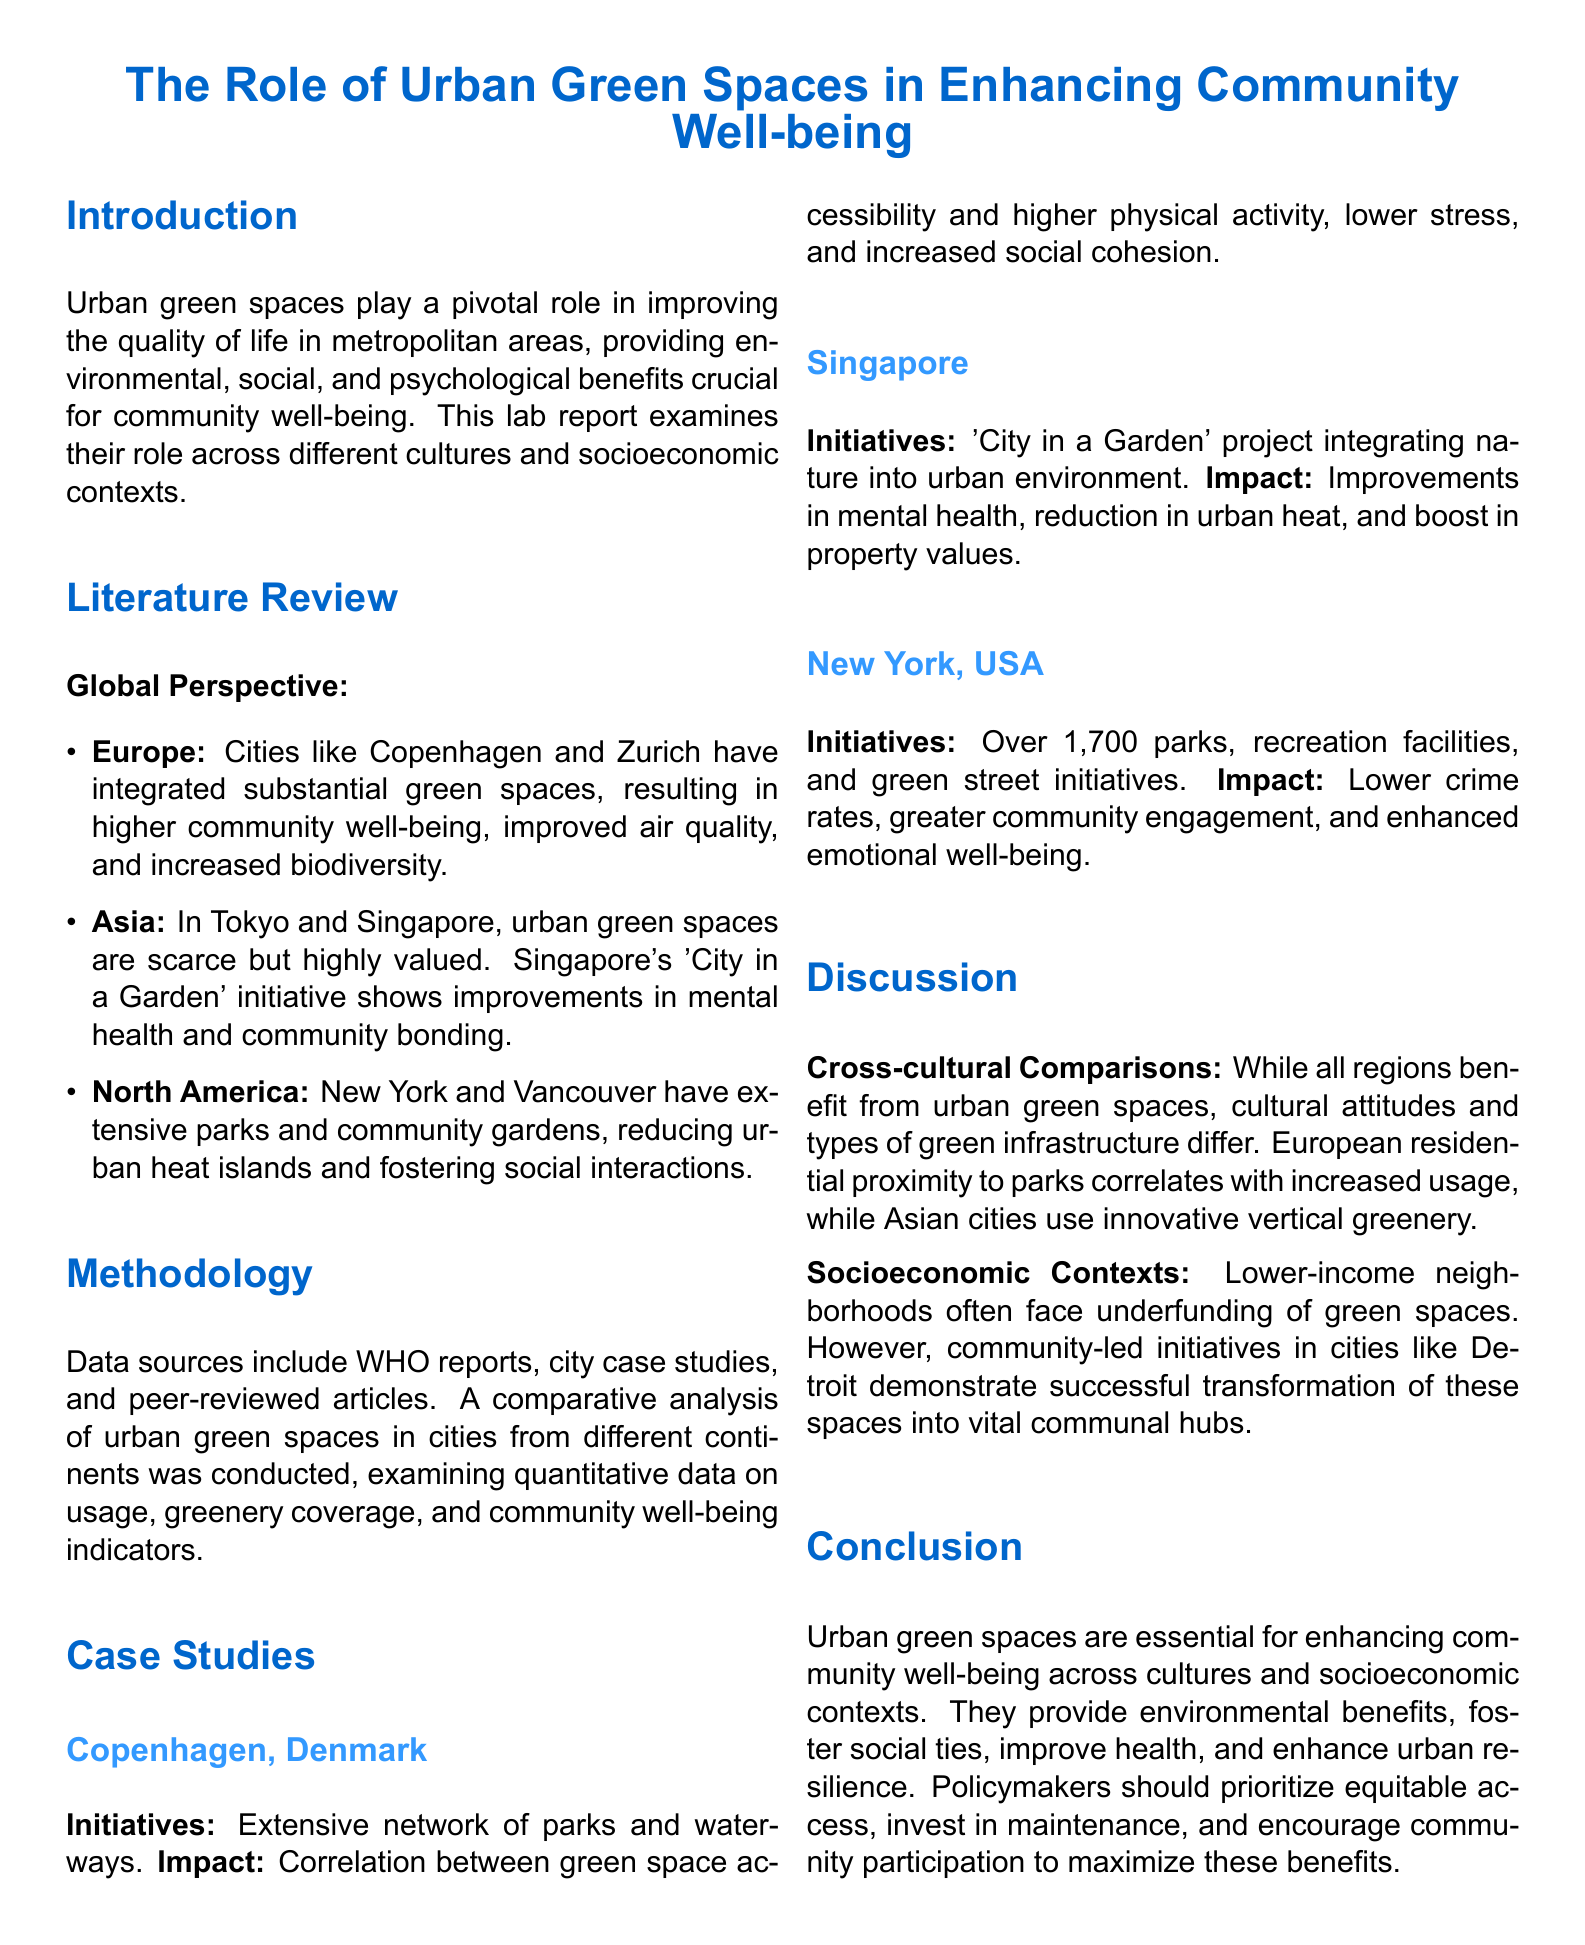What is the main focus of the lab report? The main focus is on urban green spaces and their role in enhancing community well-being across different cultures and socioeconomic contexts.
Answer: Enhancing community well-being Which city is referenced as having the 'City in a Garden' initiative? The initiative 'City in a Garden' is specifically mentioned in relation to Singapore in the case studies section.
Answer: Singapore How many parks are mentioned in New York City? The report specifies that New York City has over 1,700 parks and recreation facilities.
Answer: 1,700 What is a noted impact of green spaces in Copenhagen? The report highlights the correlation between green space accessibility and various positive outcomes like higher physical activity and lower stress in Copenhagen.
Answer: Higher physical activity What socioeconomic issue is mentioned regarding lower-income neighborhoods? The document states that lower-income neighborhoods often face underfunding of green spaces, which affects their development and maintenance.
Answer: Underfunding What type of data sources were used in the methodology? The methodology section mentions WHO reports, city case studies, and peer-reviewed articles as the data sources used for analysis.
Answer: WHO reports, city case studies, peer-reviewed articles What is one of the reported benefits of urban green spaces in New York? The document identifies lower crime rates as one of the positive impacts of extensive parks and green initiatives in New York City.
Answer: Lower crime rates Which two cities are mentioned in the global perspective section for their integration of green spaces? Copenhagen and Zurich are both identified for their substantial integration of green spaces, which positively impacts community well-being.
Answer: Copenhagen and Zurich 